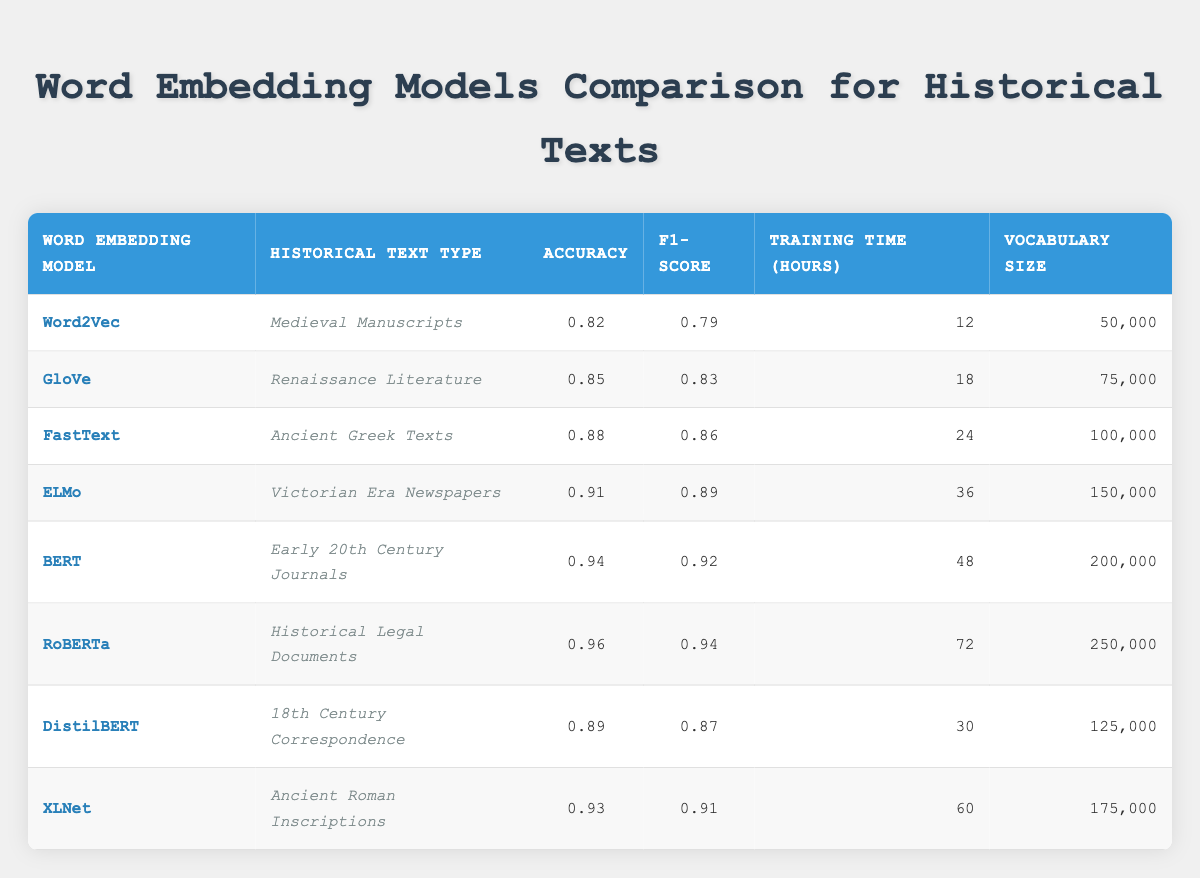What is the accuracy of the FastText model? The table shows that the accuracy for the FastText model is listed as 0.88 in the corresponding row.
Answer: 0.88 Which model has the highest F1-Score? By examining the F1-Score column, the RoBERTa model has the highest value, which is 0.94.
Answer: RoBERTa What is the average training time for all models? To find the average, add all the training times: 12 + 18 + 24 + 36 + 48 + 72 + 30 + 60 = 300. There are 8 models, so the average is 300/8 = 37.5 hours.
Answer: 37.5 Is the vocabulary size for ELMo greater than the vocabulary size for DistilBERT? The vocabulary size for ELMo is 150,000 and for DistilBERT is 125,000. Since 150,000 is greater than 125,000, the statement is true.
Answer: Yes What is the difference in accuracy between the BERT and GloVe models? The accuracy for BERT is 0.94 and GloVe is 0.85. The difference is calculated as 0.94 - 0.85 = 0.09.
Answer: 0.09 Which model was used for Ancient Roman Inscriptions and what was its training time? The table indicates that XLNet is used for Ancient Roman Inscriptions and has a training time of 60 hours.
Answer: XLNet, 60 hours Does any model have an accuracy below 0.80? By reviewing the accuracy column, the lowest accuracy is 0.82 for Word2Vec, which is above 0.80. Therefore, the answer is no.
Answer: No What is the total vocabulary size for both the ELMo and FastText models combined? The vocabulary size for ELMo is 150,000 and for FastText is 100,000. Adding these together gives 150,000 + 100,000 = 250,000.
Answer: 250,000 Which historical text type had the longest training time? Comparing the training times listed, RoBERTa has the longest training time at 72 hours for Historical Legal Documents.
Answer: Historical Legal Documents, 72 hours 